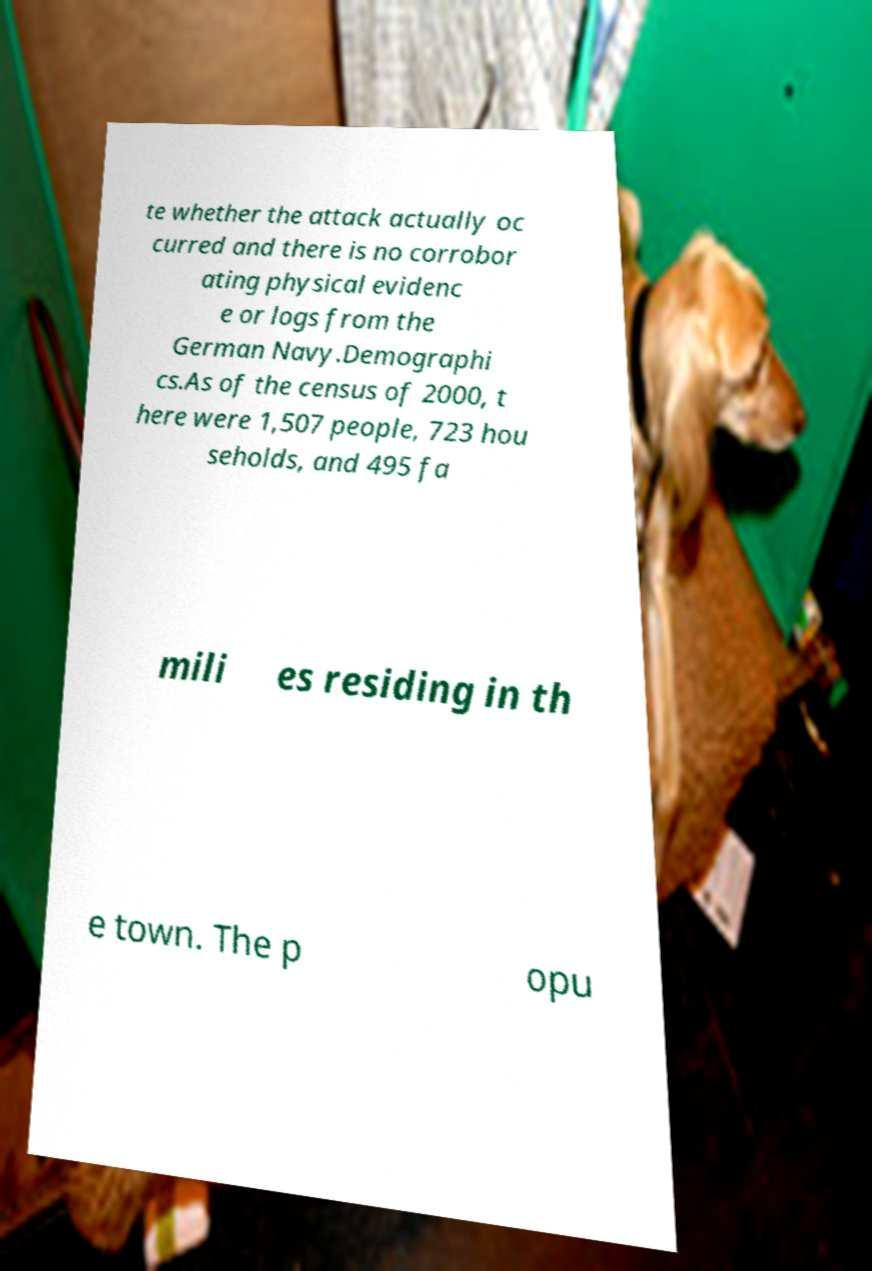Can you read and provide the text displayed in the image?This photo seems to have some interesting text. Can you extract and type it out for me? te whether the attack actually oc curred and there is no corrobor ating physical evidenc e or logs from the German Navy.Demographi cs.As of the census of 2000, t here were 1,507 people, 723 hou seholds, and 495 fa mili es residing in th e town. The p opu 